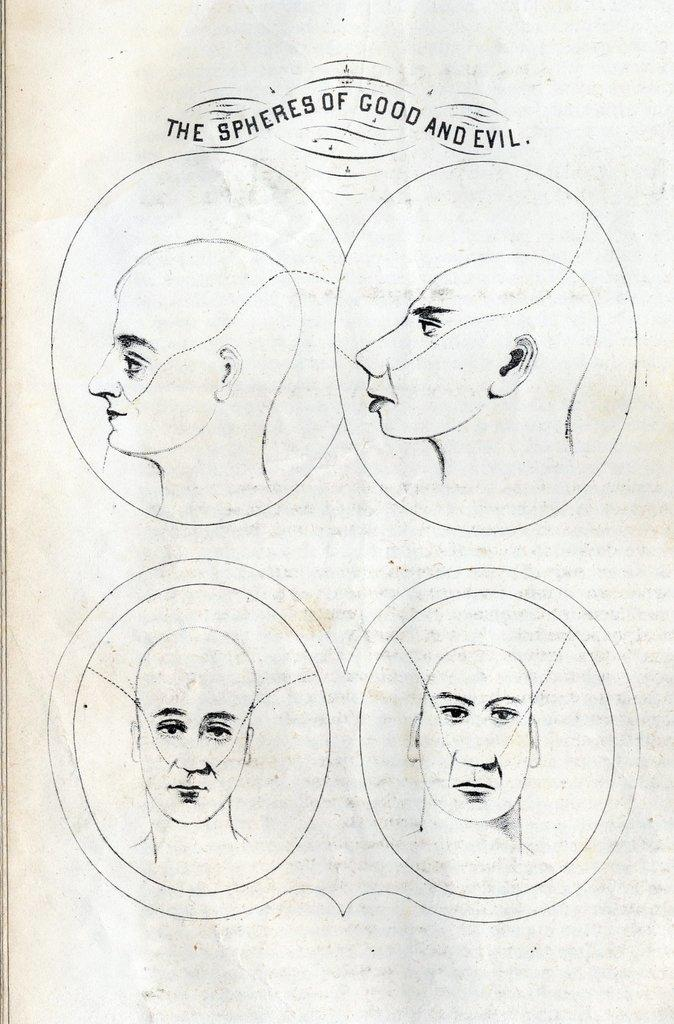What is the format of the image? The image resembles a page in a book. What can be seen in the image besides text? There are depictions of human faces in the image. Where is the text located in the image? The text is at the top of the image. What type of grain is being carried by the porter in the image? There is no porter or grain present in the image. How does the stretch of the human faces affect the overall composition of the image? The human faces in the image do not appear to be stretched, and there is no indication that stretching affects the composition. 